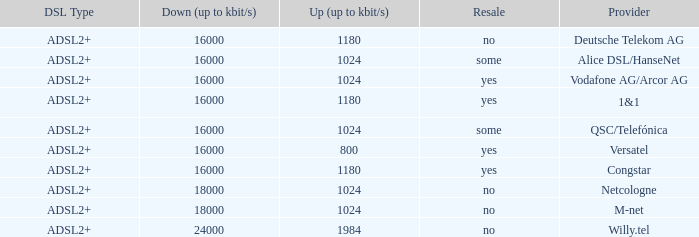What is download bandwith where the provider is deutsche telekom ag? 16000.0. 